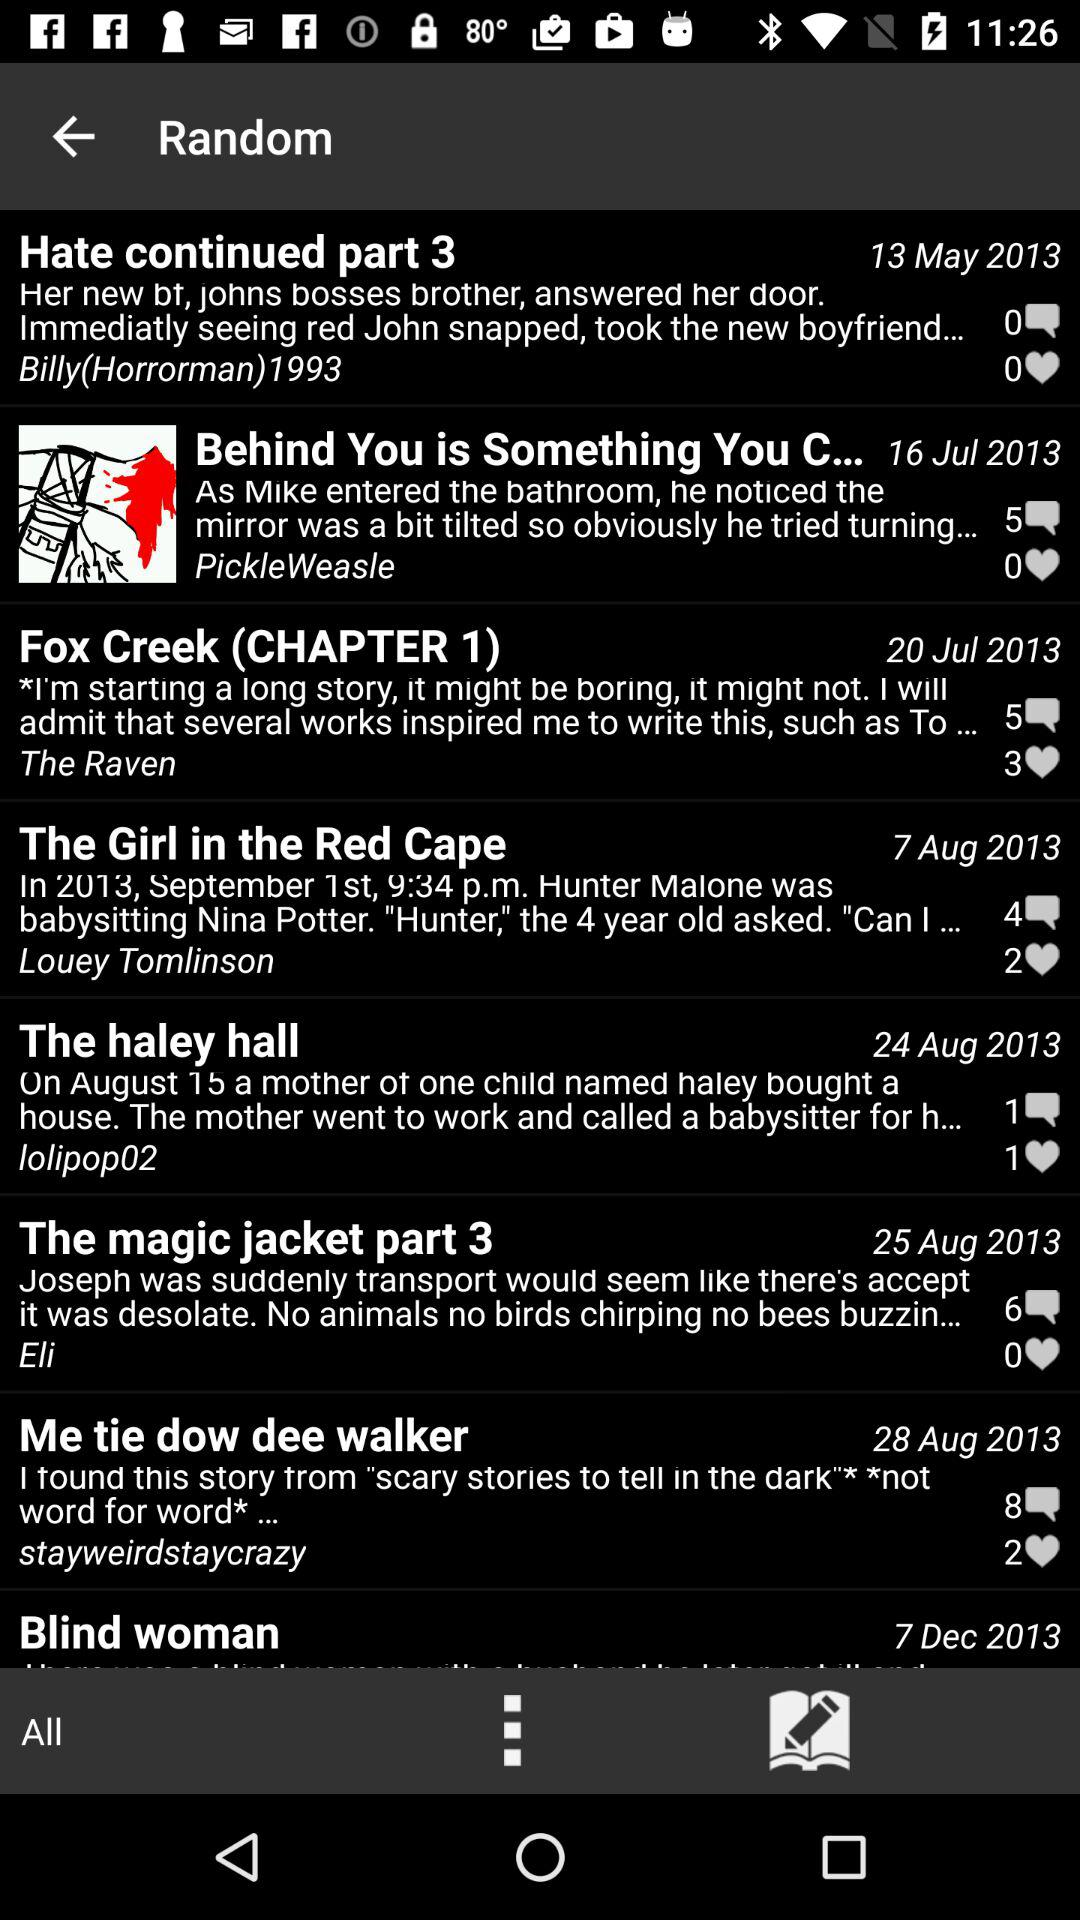On which date was "Hate continued part 3" published? "Hate continued part 3" was published on May 13, 2013. 